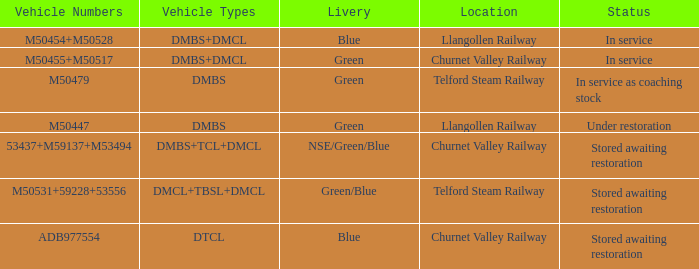What status is the vehicle numbers of adb977554? Stored awaiting restoration. 